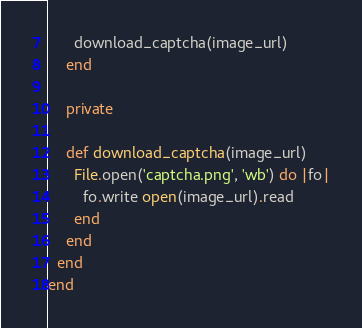Convert code to text. <code><loc_0><loc_0><loc_500><loc_500><_Ruby_>
      download_captcha(image_url)
    end

    private

    def download_captcha(image_url)
      File.open('captcha.png', 'wb') do |fo|
        fo.write open(image_url).read
      end
    end
  end
end
</code> 